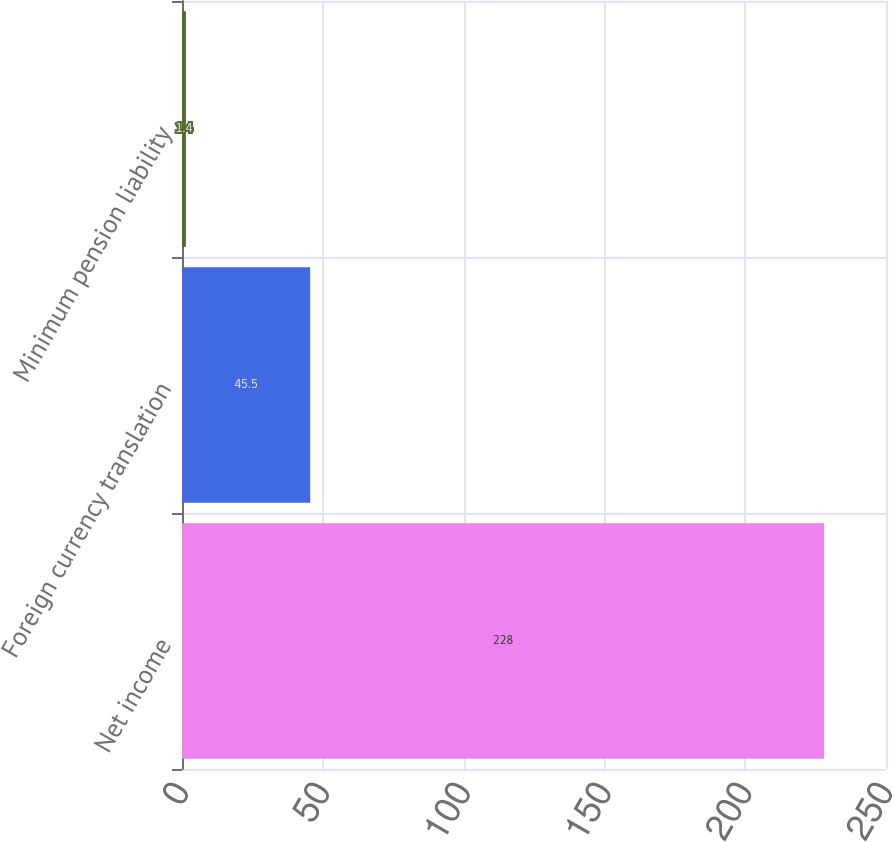Convert chart to OTSL. <chart><loc_0><loc_0><loc_500><loc_500><bar_chart><fcel>Net income<fcel>Foreign currency translation<fcel>Minimum pension liability<nl><fcel>228<fcel>45.5<fcel>1.4<nl></chart> 